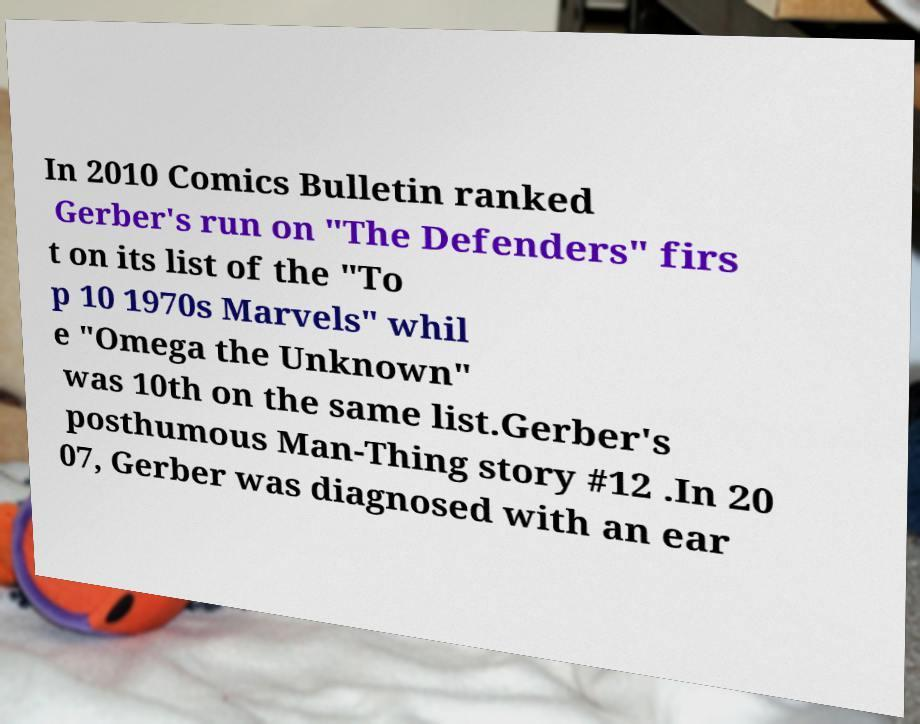Could you assist in decoding the text presented in this image and type it out clearly? In 2010 Comics Bulletin ranked Gerber's run on "The Defenders" firs t on its list of the "To p 10 1970s Marvels" whil e "Omega the Unknown" was 10th on the same list.Gerber's posthumous Man-Thing story #12 .In 20 07, Gerber was diagnosed with an ear 